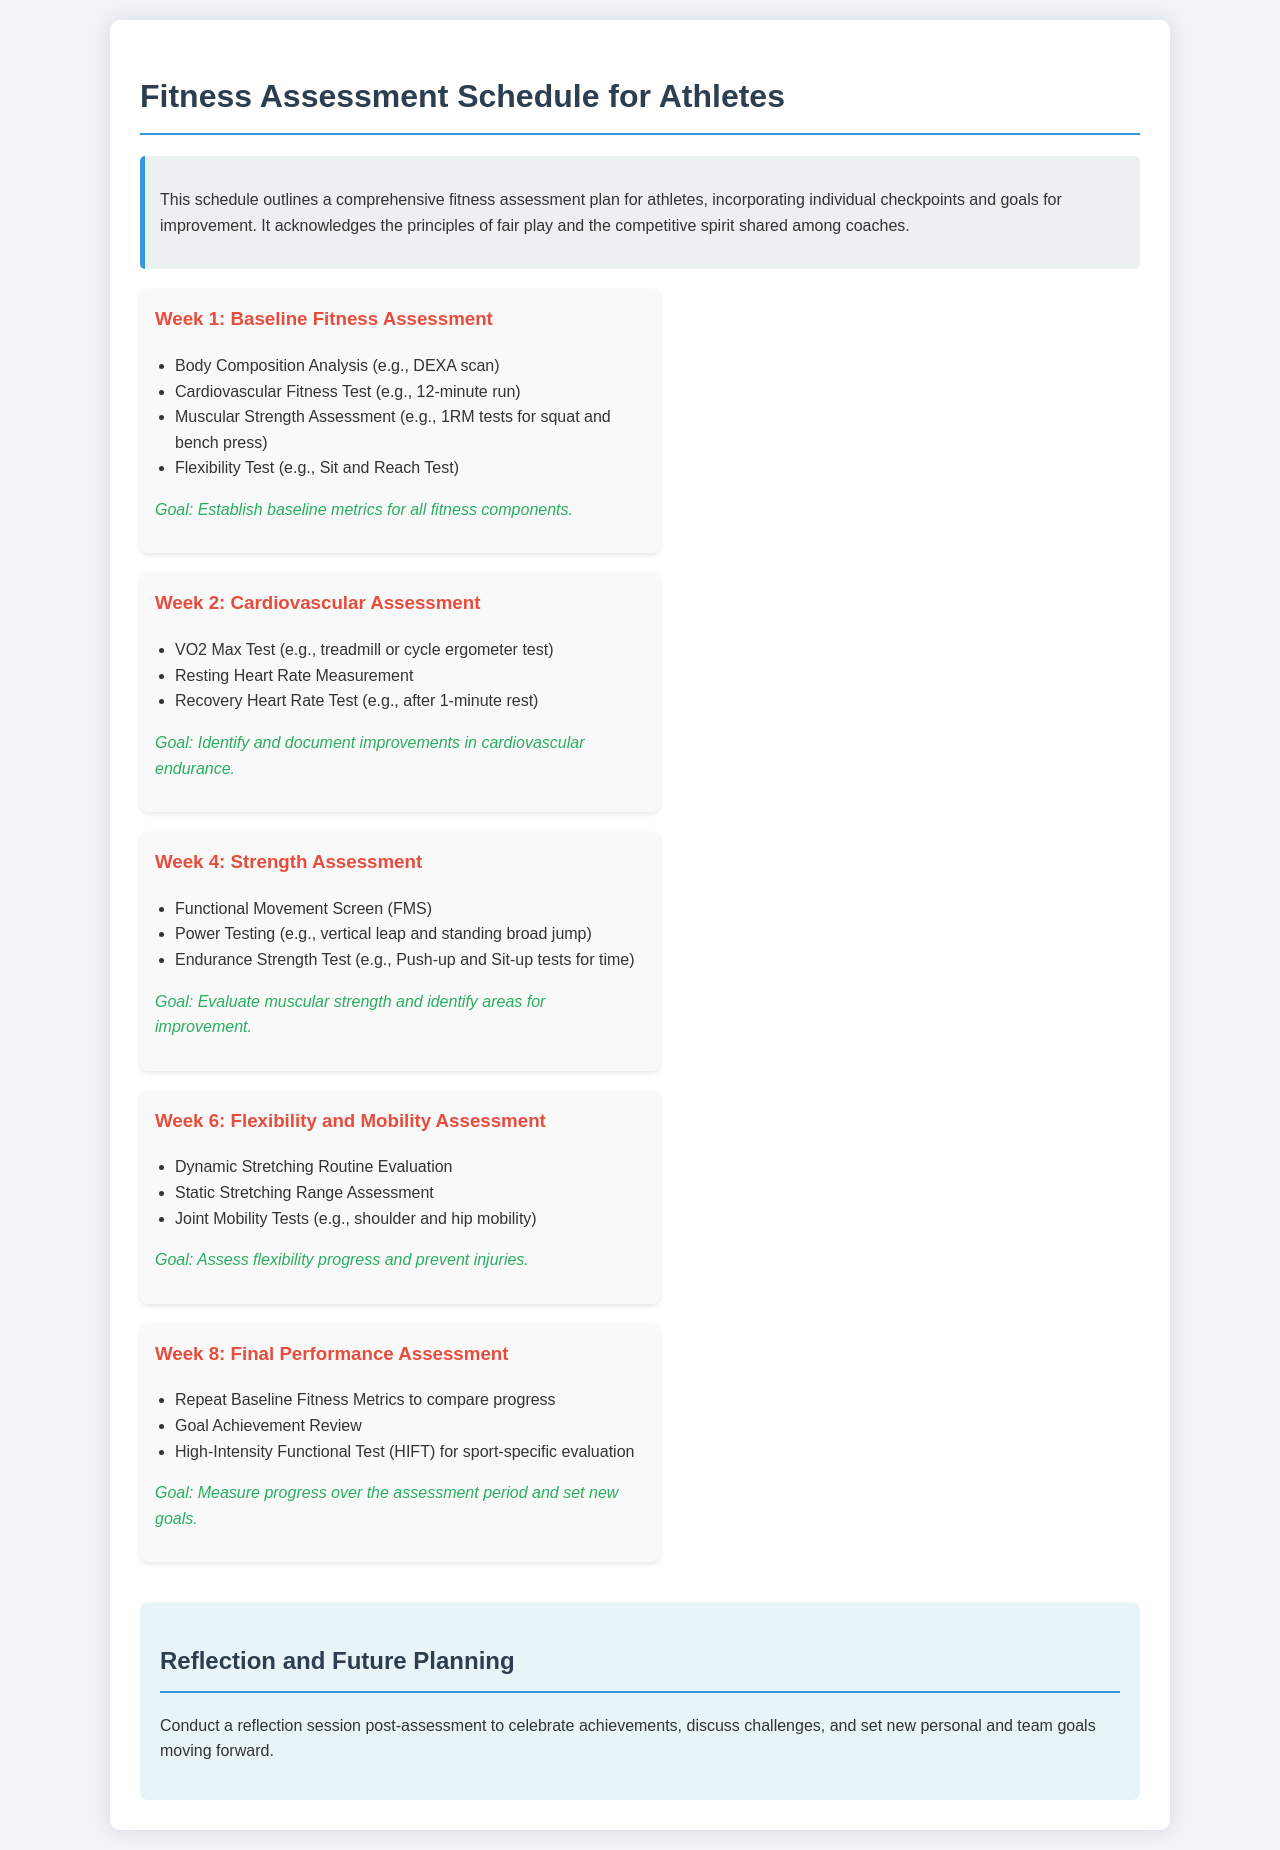What is the title of the schedule? The title of the schedule is stated at the top of the document, indicating the main focus.
Answer: Fitness Assessment Schedule for Athletes What is the goal for Week 1? Each week has a specified goal, with Week 1's goal outlined beneath its activities.
Answer: Establish baseline metrics for all fitness components What testing is performed in Week 2? The specific tests listed under Week 2 highlight its focus on a particular area of fitness.
Answer: VO2 Max Test How many weeks are included in the fitness assessment schedule? The document details the weekly structure of the assessment schedule, counting the distinct weeks mentioned.
Answer: 5 What type of assessment occurs in Week 6? The activities scheduled for Week 6 reveal its focus area, indicating the type of assessment.
Answer: Flexibility and Mobility Assessment What is one of the activities listed for Week 4? The activities for Week 4 can be directly referenced from the week’s corresponding list in the document.
Answer: Functional Movement Screen How does the schedule advise athletes to reflect after assessments? The reflection strategy is suggested as part of the document’s structure, detailing the purpose of this session.
Answer: Celebrate achievements What is one of the tests included in the final performance assessment? Week 8 includes repeat testing to measure progress, highlighting the specific types of tests conducted.
Answer: High-Intensity Functional Test What is the color of the background for the introductory section? The visual aspect of the section can be inferred from the description of the design in the document.
Answer: Light grey 